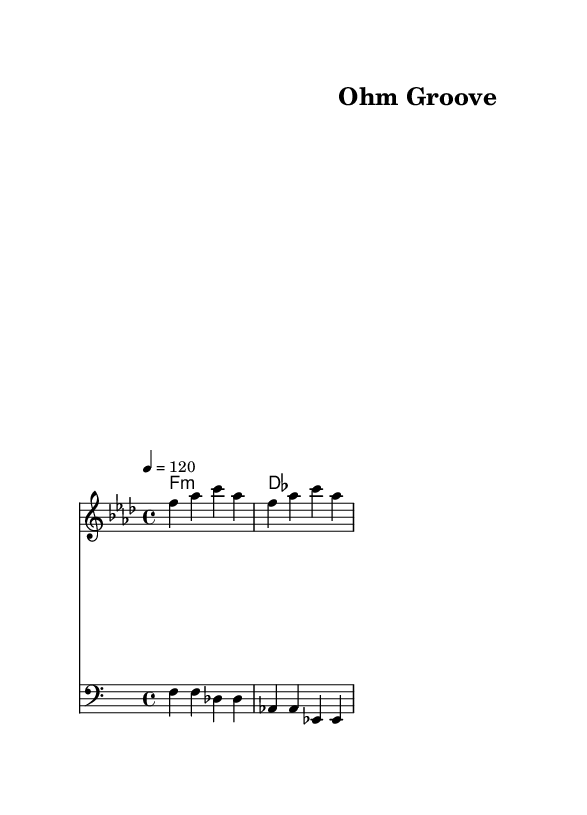What is the key signature of this music? The key signature is F minor, which has four flats. This can be confirmed by looking for the flat symbols at the beginning of the staff.
Answer: F minor What is the time signature of this music? The time signature is 4/4, indicated at the beginning of the piece with a fraction showing four beats in a measure and a quarter note receiving one beat.
Answer: 4/4 What is the tempo marking of this piece? The tempo marking is quarter note equals 120, which appears in the global section of the code. This means there are 120 quarter note beats per minute.
Answer: 120 What type of chords are used in the harmony? The chords in the harmony are minor chords and one major chord, as indicated by "f1:m" (F minor) and "des1" (D flat major).
Answer: Minor How many measures are in the melody line? The melody line contains two measures as seen by counting the pairs of notes within the staff. Each measure generally contains the same number of beats as dictated by the time signature, so we deduce this by examining the note groupings.
Answer: 2 What is the mantra lyric repeated throughout this piece? The repeated lyric is "Ohm ma ni pad me hum," visible directly below the melody line in the lyric mode. This lyrical chant is a transliteration of a well-known mantra.
Answer: Ohm ma ni pad me hum 